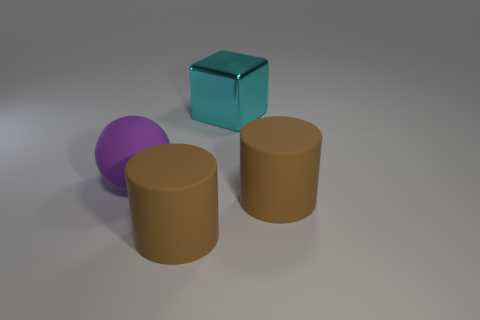Add 3 large rubber things. How many objects exist? 7 Subtract all blocks. How many objects are left? 3 Subtract all big matte cylinders. Subtract all matte balls. How many objects are left? 1 Add 3 cylinders. How many cylinders are left? 5 Add 4 rubber objects. How many rubber objects exist? 7 Subtract 0 red spheres. How many objects are left? 4 